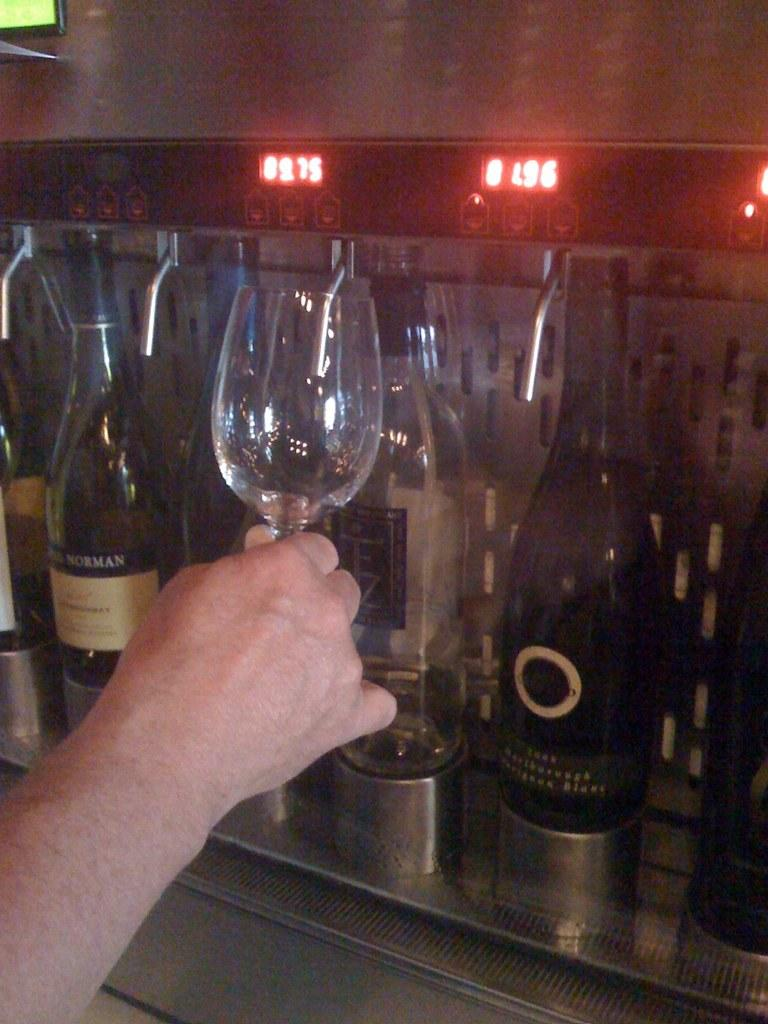Who is present in the image? There is a person in the image. What is the person holding in the image? The person is holding a glass. What else can be seen in the image besides the person and the glass? There are bottles visible in the image. What time of day is it in the image, given the presence of the sea? There is no sea present in the image, so it is not possible to determine the time of day based on that information. 